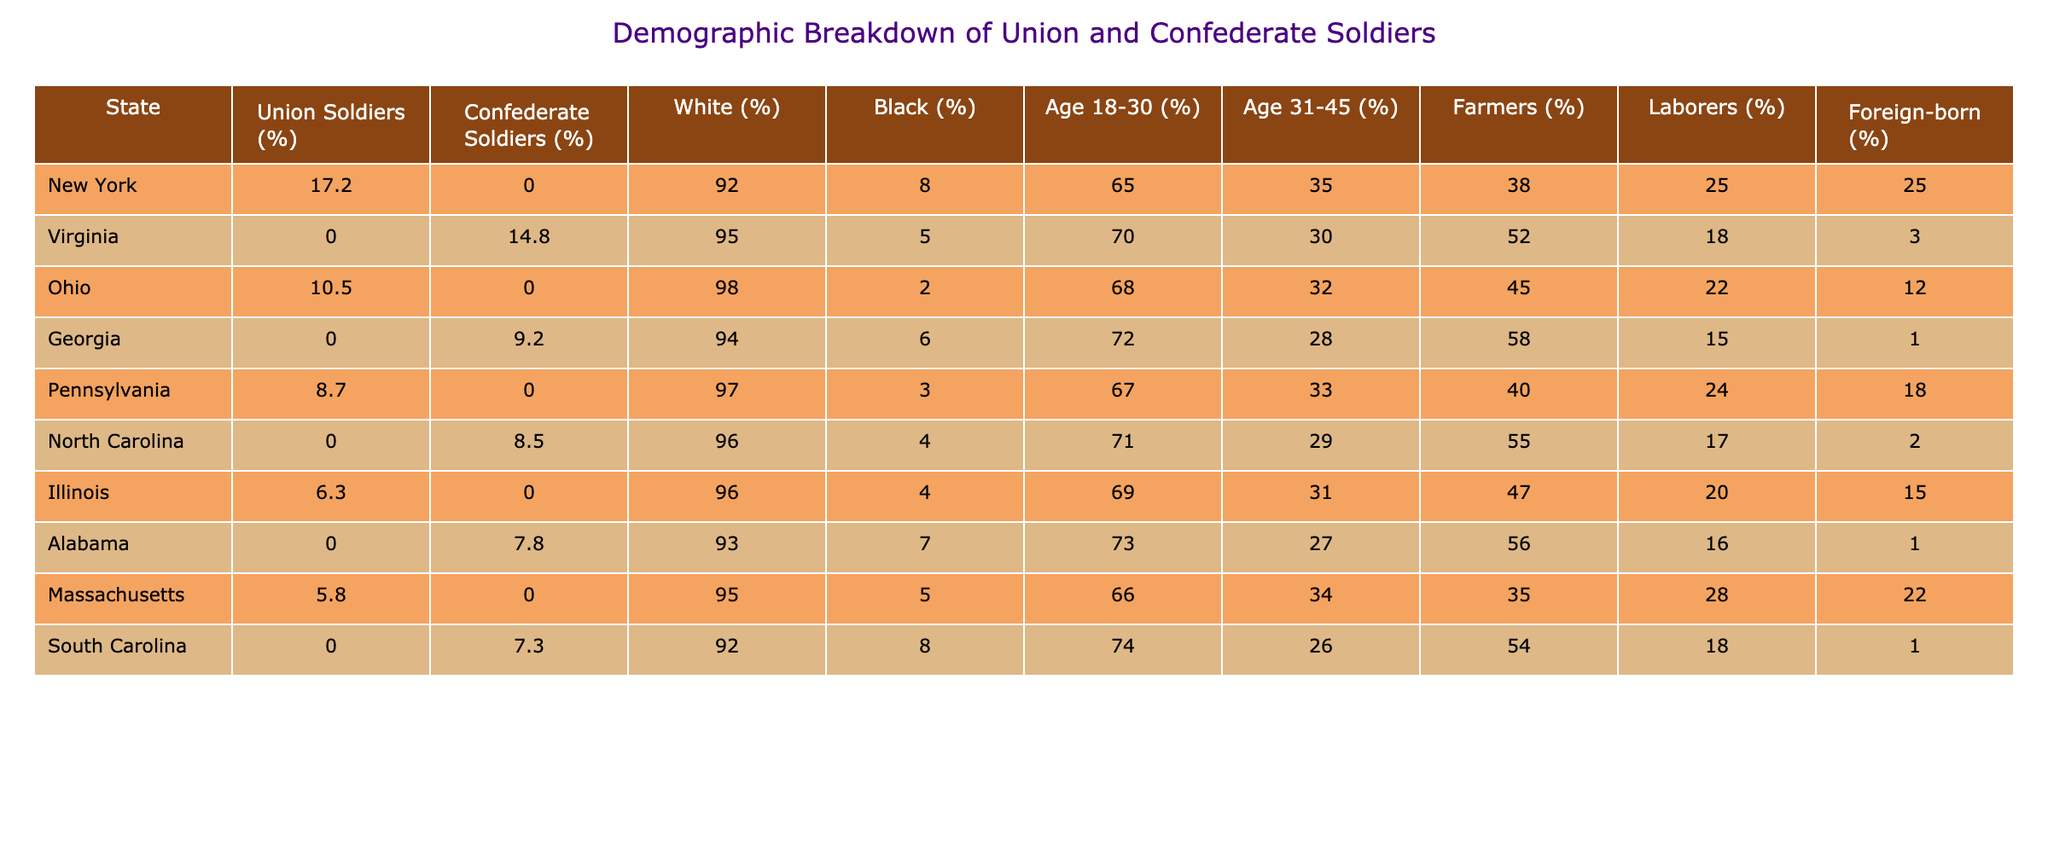What percentage of Union soldiers came from Pennsylvania? From the table, the percentage of Union soldiers from Pennsylvania is listed directly under the Union Soldiers (%) column. It shows a value of 8.7%.
Answer: 8.7% What is the percentage of Black soldiers in Virginia? The table shows that the percentage of Black soldiers in Virginia is directly available in the Black (%) column. The value is 5%.
Answer: 5% Which state has the highest percentage of Confederate soldiers? By examining the Confederate Soldiers (%) column, Virginia has the highest value of 14.8%, indicating the largest percentage of Confederate soldiers among the states listed.
Answer: Virginia What is the difference in the percentage of Union soldiers between New York and Illinois? First, find the Union soldiers' percentages for both states: New York has 17.2% and Illinois has 6.3%. Calculate the difference: 17.2% - 6.3% = 10.9%.
Answer: 10.9% Which state has the highest percentage of foreign-born soldiers? The foreign-born (%) column is checked. New York has the highest percentage of 25%, compared to other states like Pennsylvania (18%) and Illinois (15%).
Answer: New York What is the average percentage of Union soldiers across all states listed? To find the average, sum all the Union soldiers' percentages (17.2 + 10.5 + 8.7 + 6.3 + 5.8) = 48.5 and divide by the number of states (5): 48.5 / 5 = 9.7%.
Answer: 9.7% Is the percentage of farmers higher among Union or Confederate soldiers in Georgia? In Georgia, the percentage of farmers among Confederate soldiers is 58%, whereas the Union soldiers have a percentage of farmers that is not listed. Since there's no Union data for farmers in Georgia, only the Confederate percentage can be considered.
Answer: Yes What is the total percentage of soldiers aged 31-45 in New York and Pennsylvania combined? First, find the percentages for New York (35%) and Pennsylvania (33%). Then, add them together: 35% + 33% = 68%.
Answer: 68% Does South Carolina have a higher percentage of Confederate soldiers or farmers, and by how much? South Carolina has 7.3% Confederate soldiers and 54% farmers. The difference is 54% - 7.3% = 46.7%, showing that farmers have a significantly larger percentage.
Answer: Farmers by 46.7% How many states have a percentage of Black soldiers above 5%? From the table, the states with Black soldiers above 5% are New York (8%), Virginia (5%), Alabama (7%), and South Carolina (8%). That gives us 3 states above 5%.
Answer: 3 states 